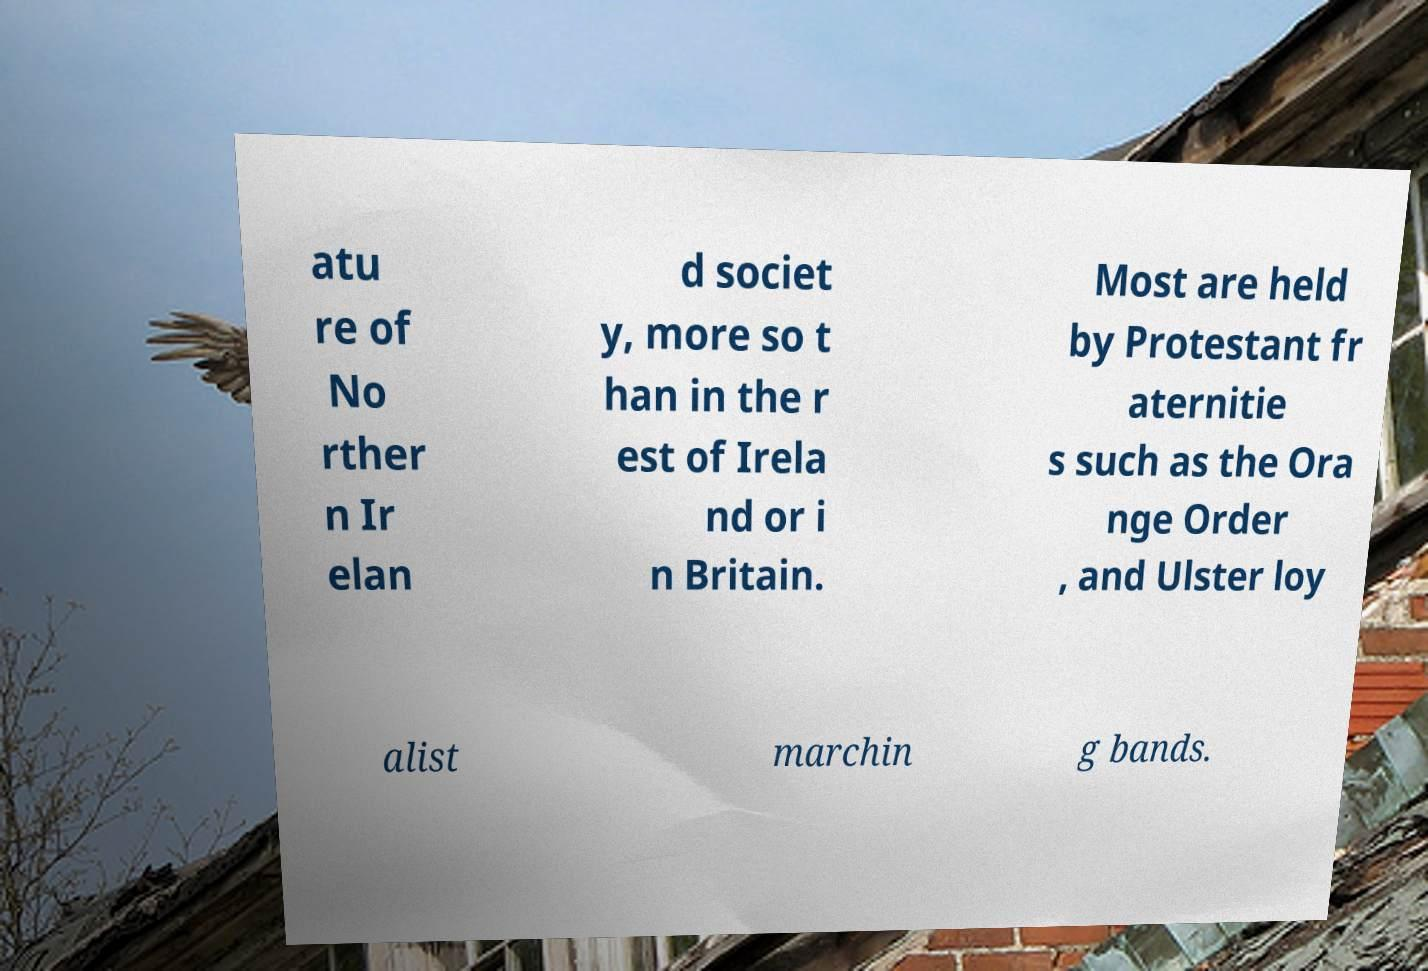Please read and relay the text visible in this image. What does it say? atu re of No rther n Ir elan d societ y, more so t han in the r est of Irela nd or i n Britain. Most are held by Protestant fr aternitie s such as the Ora nge Order , and Ulster loy alist marchin g bands. 